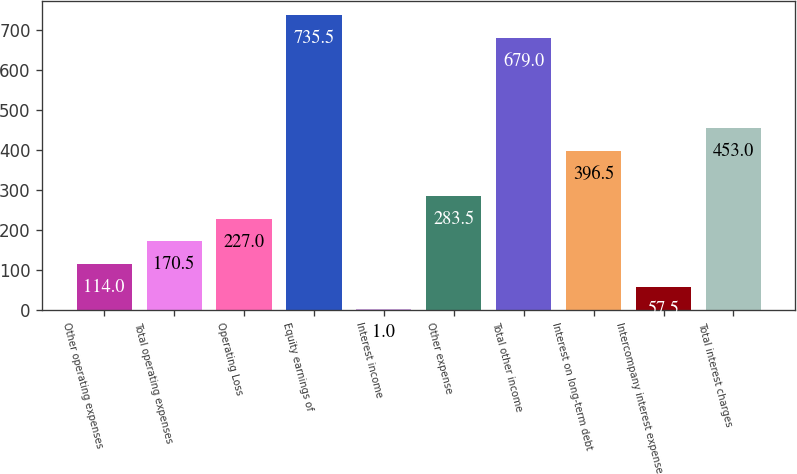Convert chart. <chart><loc_0><loc_0><loc_500><loc_500><bar_chart><fcel>Other operating expenses<fcel>Total operating expenses<fcel>Operating Loss<fcel>Equity earnings of<fcel>Interest income<fcel>Other expense<fcel>Total other income<fcel>Interest on long-term debt<fcel>Intercompany interest expense<fcel>Total interest charges<nl><fcel>114<fcel>170.5<fcel>227<fcel>735.5<fcel>1<fcel>283.5<fcel>679<fcel>396.5<fcel>57.5<fcel>453<nl></chart> 